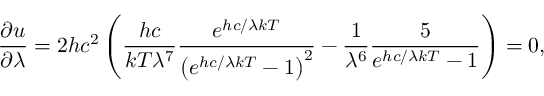<formula> <loc_0><loc_0><loc_500><loc_500>{ \frac { \partial u } { \partial \lambda } } = 2 h c ^ { 2 } \left ( { \frac { h c } { k T \lambda ^ { 7 } } } { \frac { e ^ { h c / \lambda k T } } { \left ( e ^ { h c / \lambda k T } - 1 \right ) ^ { 2 } } } - { \frac { 1 } { \lambda ^ { 6 } } } { \frac { 5 } { e ^ { h c / \lambda k T } - 1 } } \right ) = 0 ,</formula> 